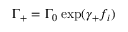Convert formula to latex. <formula><loc_0><loc_0><loc_500><loc_500>\Gamma _ { + } = \Gamma _ { 0 } \exp ( \gamma _ { + } f _ { i } )</formula> 